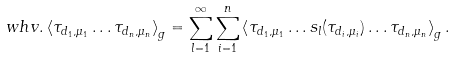<formula> <loc_0><loc_0><loc_500><loc_500>\ w h v . \left < \tau _ { d _ { 1 } , \mu _ { 1 } } \dots \tau _ { d _ { n } , \mu _ { n } } \right > _ { g } = \sum _ { l = 1 } ^ { \infty } \sum _ { i = 1 } ^ { n } \left < \tau _ { d _ { 1 } , \mu _ { 1 } } \dots s _ { l } ( \tau _ { d _ { i } , \mu _ { i } } ) \dots \tau _ { d _ { n } , \mu _ { n } } \right > _ { g } .</formula> 